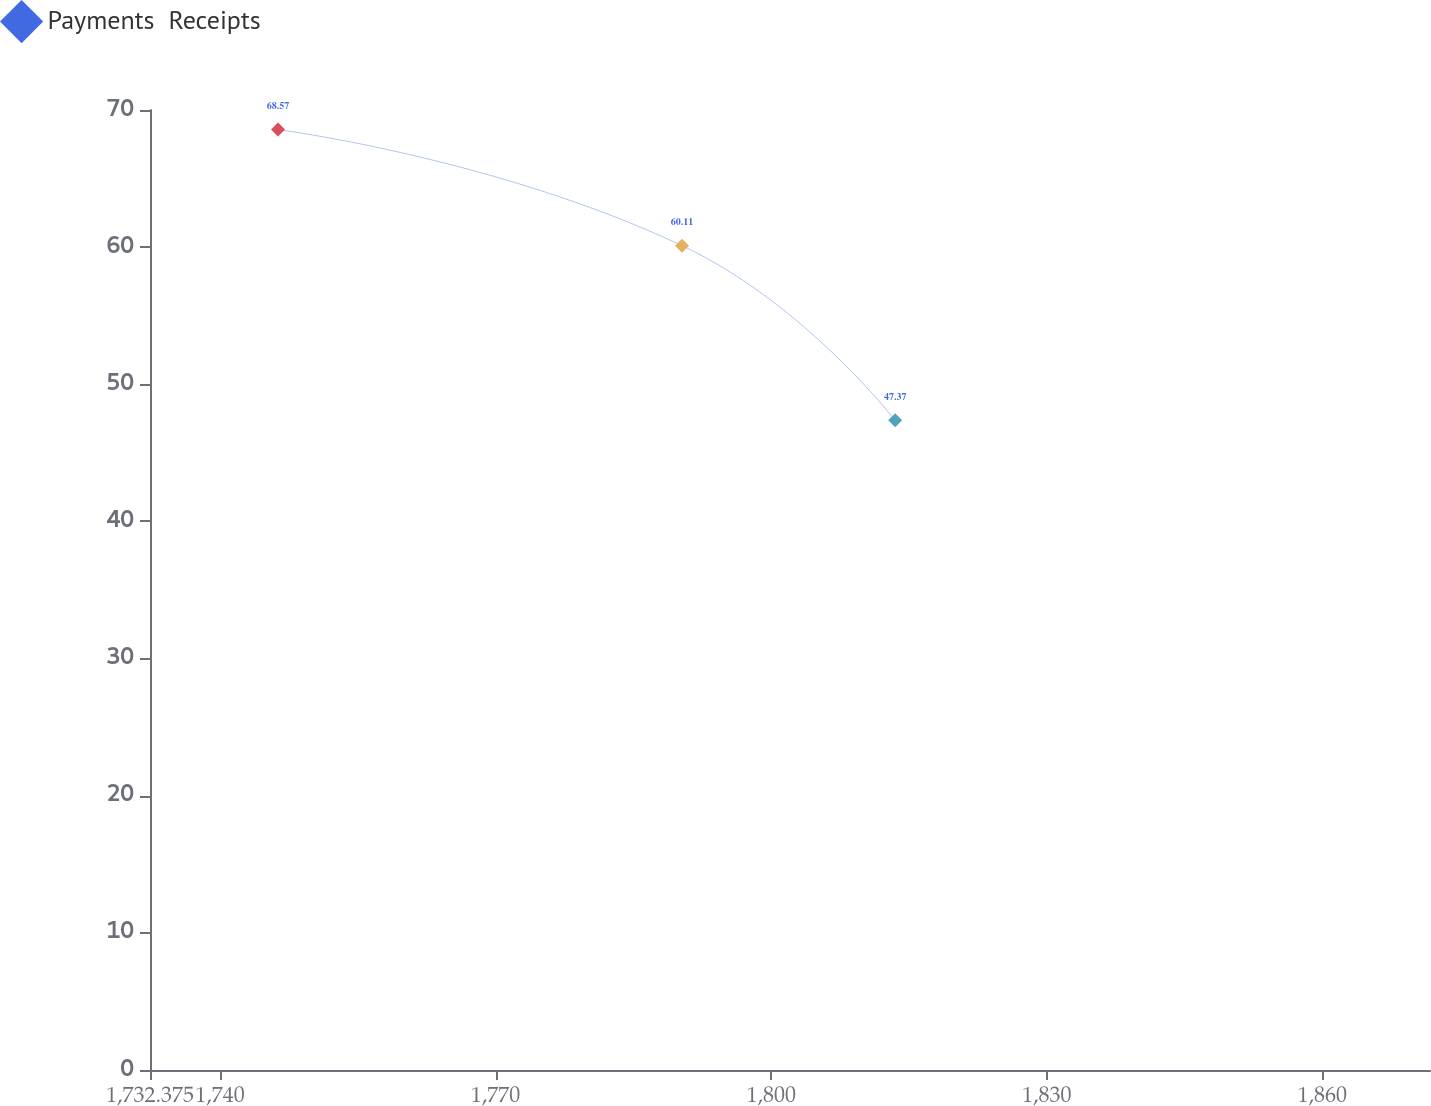Convert chart. <chart><loc_0><loc_0><loc_500><loc_500><line_chart><ecel><fcel>Payments  Receipts<nl><fcel>1746.31<fcel>68.57<nl><fcel>1790.3<fcel>60.11<nl><fcel>1813.5<fcel>47.37<nl><fcel>1885.66<fcel>49.49<nl></chart> 